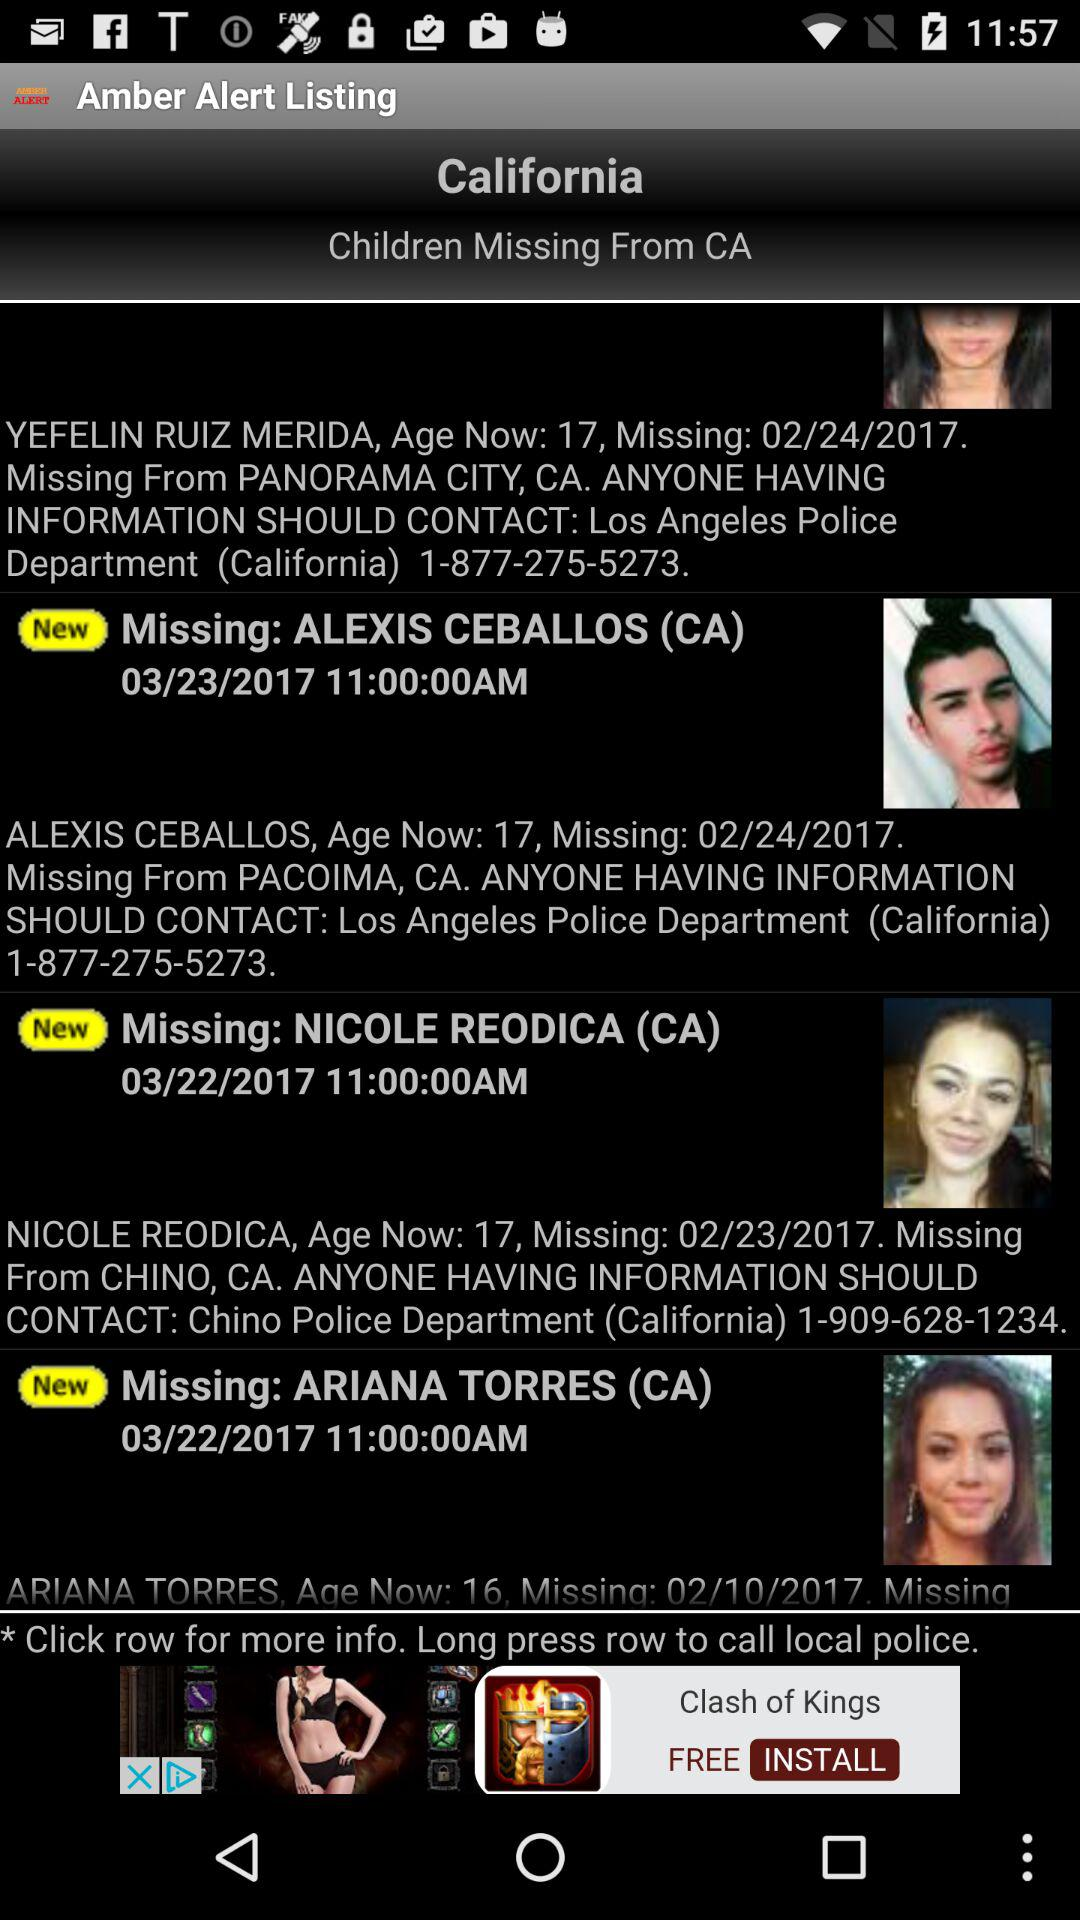From where is Alexis Ceballos missing? Alexis Ceballos is missing from Pacoima, CA. 